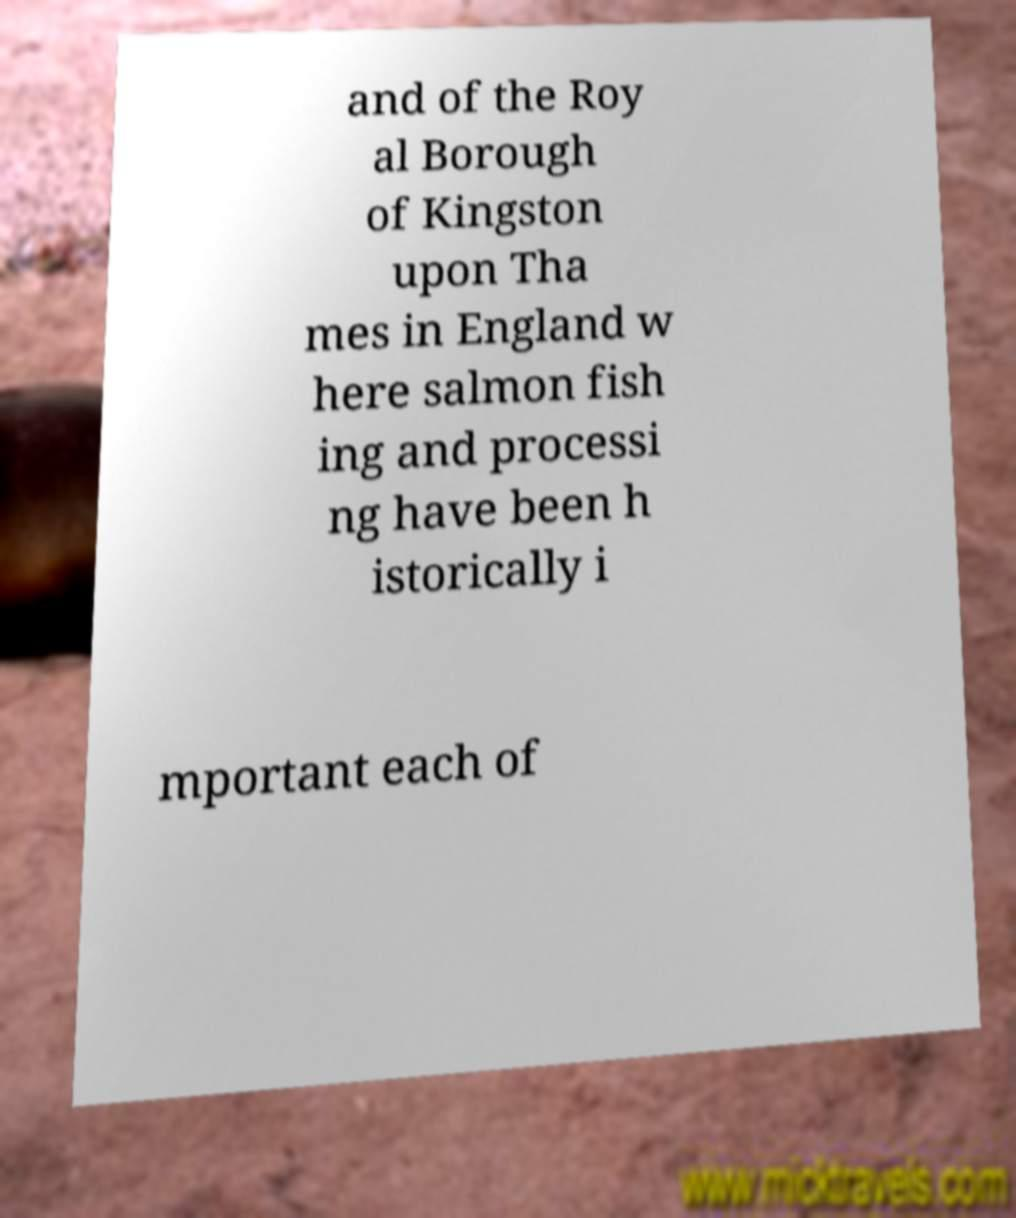For documentation purposes, I need the text within this image transcribed. Could you provide that? and of the Roy al Borough of Kingston upon Tha mes in England w here salmon fish ing and processi ng have been h istorically i mportant each of 